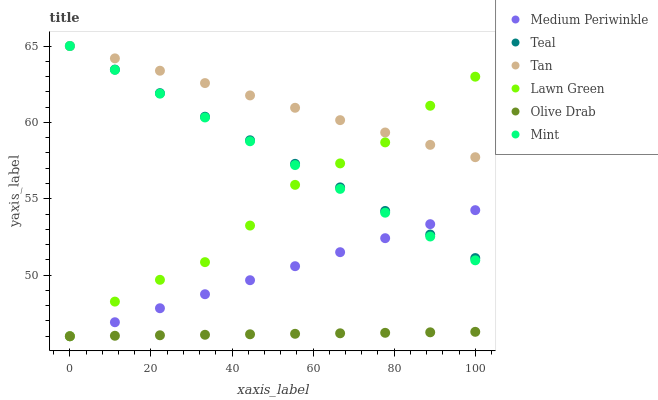Does Olive Drab have the minimum area under the curve?
Answer yes or no. Yes. Does Tan have the maximum area under the curve?
Answer yes or no. Yes. Does Medium Periwinkle have the minimum area under the curve?
Answer yes or no. No. Does Medium Periwinkle have the maximum area under the curve?
Answer yes or no. No. Is Olive Drab the smoothest?
Answer yes or no. Yes. Is Lawn Green the roughest?
Answer yes or no. Yes. Is Medium Periwinkle the smoothest?
Answer yes or no. No. Is Medium Periwinkle the roughest?
Answer yes or no. No. Does Lawn Green have the lowest value?
Answer yes or no. Yes. Does Teal have the lowest value?
Answer yes or no. No. Does Mint have the highest value?
Answer yes or no. Yes. Does Medium Periwinkle have the highest value?
Answer yes or no. No. Is Medium Periwinkle less than Tan?
Answer yes or no. Yes. Is Teal greater than Olive Drab?
Answer yes or no. Yes. Does Lawn Green intersect Medium Periwinkle?
Answer yes or no. Yes. Is Lawn Green less than Medium Periwinkle?
Answer yes or no. No. Is Lawn Green greater than Medium Periwinkle?
Answer yes or no. No. Does Medium Periwinkle intersect Tan?
Answer yes or no. No. 